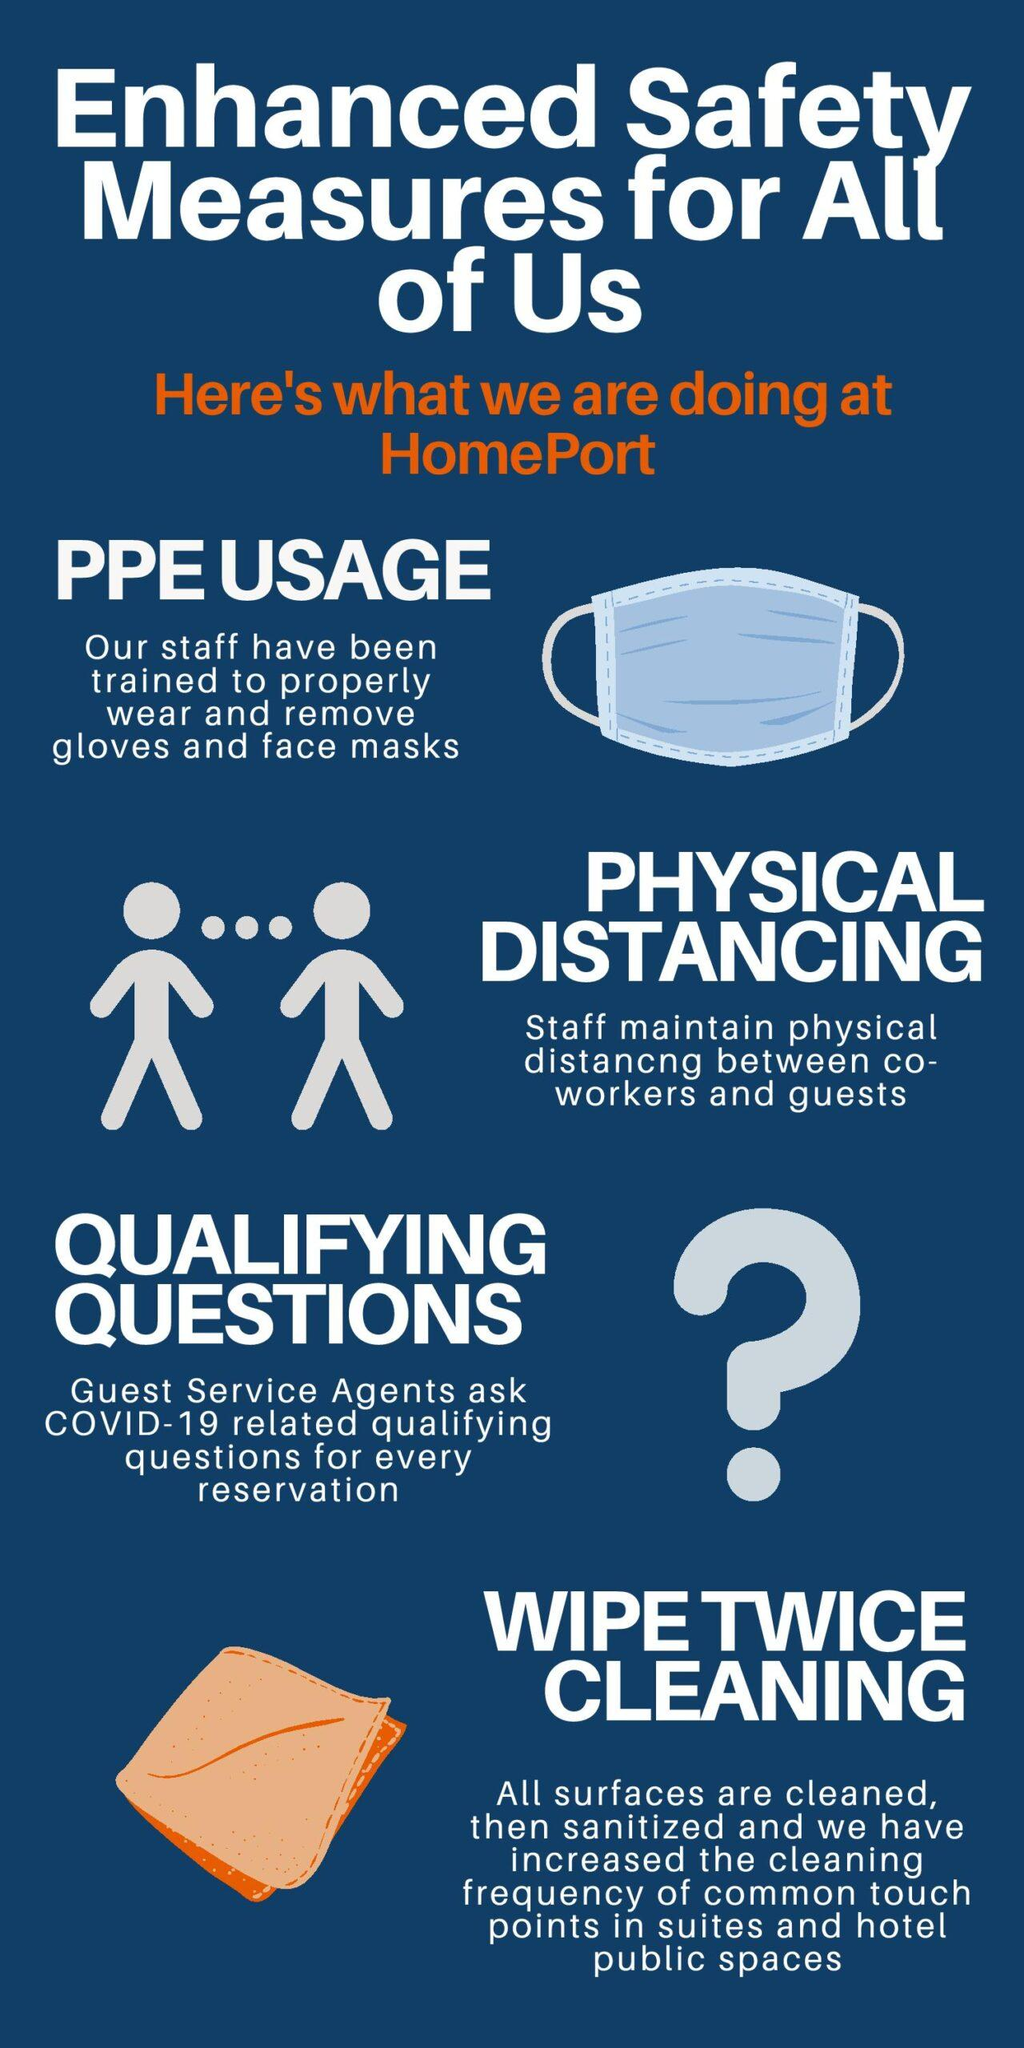Highlight a few significant elements in this photo. The safety measures taken at the homeport, in addition to the usage of personal protective equipment (PPE) and physical distancing, include qualified wipe cleaning procedures. 